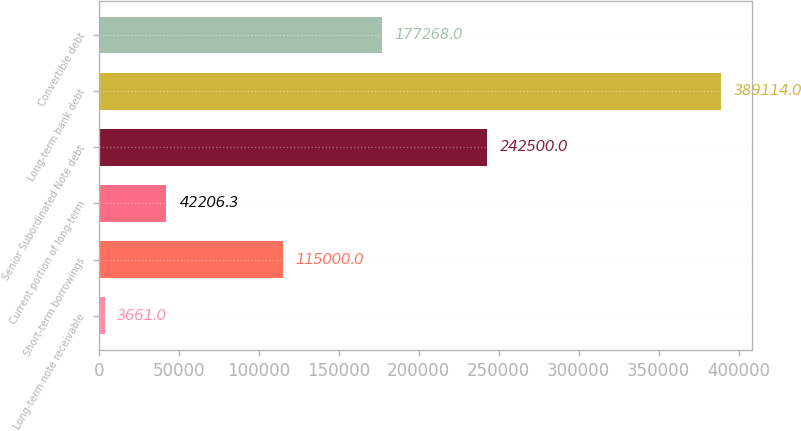Convert chart to OTSL. <chart><loc_0><loc_0><loc_500><loc_500><bar_chart><fcel>Long-term note receivable<fcel>Short-term borrowings<fcel>Current portion of long-term<fcel>Senior Subordinated Note debt<fcel>Long-term bank debt<fcel>Convertible debt<nl><fcel>3661<fcel>115000<fcel>42206.3<fcel>242500<fcel>389114<fcel>177268<nl></chart> 